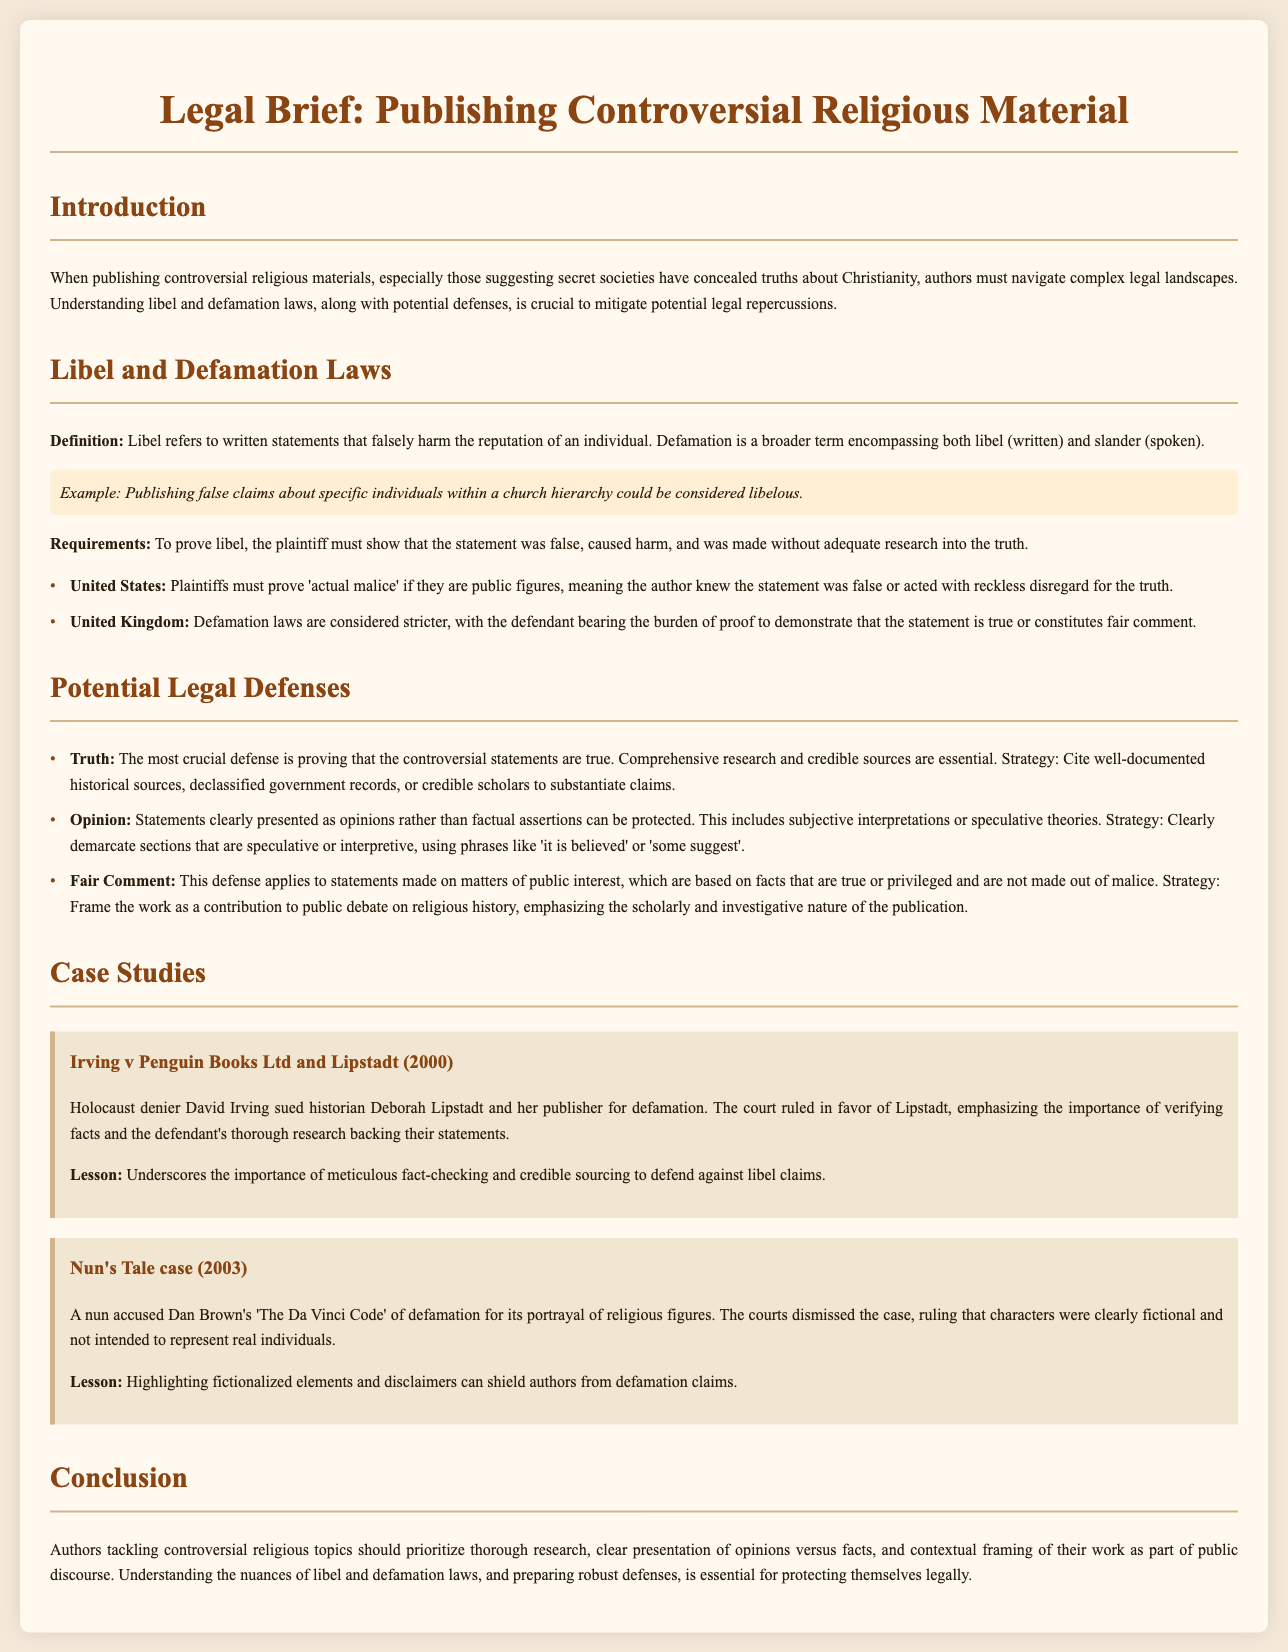What is the primary focus of the legal brief? The primary focus of the legal brief is to help authors navigate legal issues when publishing controversial religious materials related to secret societies and Christianity.
Answer: Legal issues for authors What is the first requirement to prove libel? The first requirement to prove libel is that the plaintiff must show that the statement was false.
Answer: Statement was false What case emphasized the importance of verifying facts? The case Irving v Penguin Books Ltd and Lipstadt (2000) emphasized the importance of verifying facts.
Answer: Irving v Penguin Books Ltd What defense can be used if statements are presented as opinions? The defense is "Opinion" when statements are clearly presented as opinions rather than facts.
Answer: Opinion What year was the Nun's Tale case decided? The Nun's Tale case was decided in 2003.
Answer: 2003 What is the notable lesson from the case involving Dan Brown's book? The notable lesson is that highlighting fictionalized elements and disclaimers can shield authors from defamation claims.
Answer: Highlighting fictional elements What term refers to written statements that harm someone's reputation? The term is Libel, referring to written statements that falsely harm the reputation of an individual.
Answer: Libel What legal concept requires proof of 'actual malice' for public figures? The legal concept is 'actual malice' which requires that public figures prove the author knew the statement was false.
Answer: Actual malice What type of law is considered stricter in the UK according to the document? Defamation laws are considered stricter in the UK.
Answer: Defamation laws 